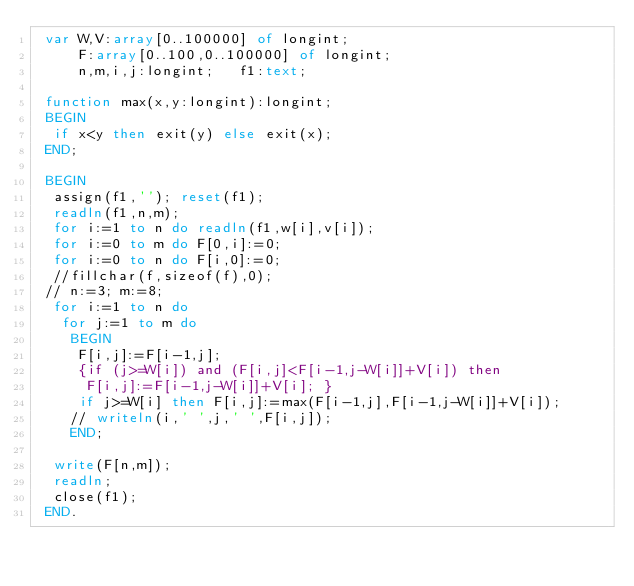Convert code to text. <code><loc_0><loc_0><loc_500><loc_500><_Pascal_> var W,V:array[0..100000] of longint;
     F:array[0..100,0..100000] of longint;
     n,m,i,j:longint;   f1:text;

 function max(x,y:longint):longint;
 BEGIN
  if x<y then exit(y) else exit(x);
 END;

 BEGIN
  assign(f1,''); reset(f1);
  readln(f1,n,m);
  for i:=1 to n do readln(f1,w[i],v[i]);
  for i:=0 to m do F[0,i]:=0;
  for i:=0 to n do F[i,0]:=0;
  //fillchar(f,sizeof(f),0);
 // n:=3; m:=8;
  for i:=1 to n do
   for j:=1 to m do
    BEGIN
     F[i,j]:=F[i-1,j];
     {if (j>=W[i]) and (F[i,j]<F[i-1,j-W[i]]+V[i]) then
      F[i,j]:=F[i-1,j-W[i]]+V[i]; }
     if j>=W[i] then F[i,j]:=max(F[i-1,j],F[i-1,j-W[i]]+V[i]);
    // writeln(i,' ',j,' ',F[i,j]);
    END;

  write(F[n,m]);
  readln;
  close(f1);
 END.

</code> 